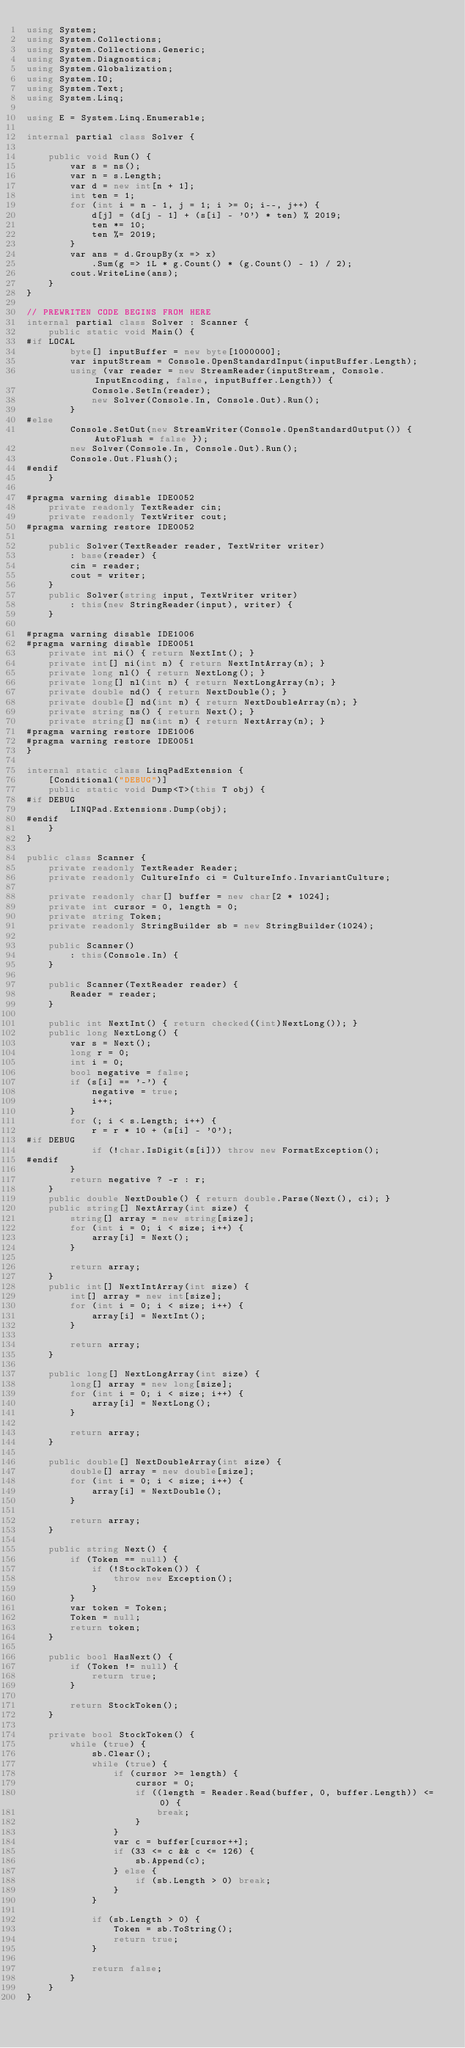<code> <loc_0><loc_0><loc_500><loc_500><_C#_>using System;
using System.Collections;
using System.Collections.Generic;
using System.Diagnostics;
using System.Globalization;
using System.IO;
using System.Text;
using System.Linq;

using E = System.Linq.Enumerable;

internal partial class Solver {

    public void Run() {
        var s = ns();
        var n = s.Length;
        var d = new int[n + 1];
        int ten = 1;
        for (int i = n - 1, j = 1; i >= 0; i--, j++) {
            d[j] = (d[j - 1] + (s[i] - '0') * ten) % 2019;
            ten *= 10;
            ten %= 2019;
        }
        var ans = d.GroupBy(x => x)
            .Sum(g => 1L * g.Count() * (g.Count() - 1) / 2);
        cout.WriteLine(ans);
    }
}

// PREWRITEN CODE BEGINS FROM HERE
internal partial class Solver : Scanner {
    public static void Main() {
#if LOCAL
        byte[] inputBuffer = new byte[1000000];
        var inputStream = Console.OpenStandardInput(inputBuffer.Length);
        using (var reader = new StreamReader(inputStream, Console.InputEncoding, false, inputBuffer.Length)) {
            Console.SetIn(reader);
            new Solver(Console.In, Console.Out).Run();
        }
#else
        Console.SetOut(new StreamWriter(Console.OpenStandardOutput()) { AutoFlush = false });
        new Solver(Console.In, Console.Out).Run();
        Console.Out.Flush();
#endif
    }

#pragma warning disable IDE0052
    private readonly TextReader cin;
    private readonly TextWriter cout;
#pragma warning restore IDE0052

    public Solver(TextReader reader, TextWriter writer)
        : base(reader) {
        cin = reader;
        cout = writer;
    }
    public Solver(string input, TextWriter writer)
        : this(new StringReader(input), writer) {
    }

#pragma warning disable IDE1006
#pragma warning disable IDE0051
    private int ni() { return NextInt(); }
    private int[] ni(int n) { return NextIntArray(n); }
    private long nl() { return NextLong(); }
    private long[] nl(int n) { return NextLongArray(n); }
    private double nd() { return NextDouble(); }
    private double[] nd(int n) { return NextDoubleArray(n); }
    private string ns() { return Next(); }
    private string[] ns(int n) { return NextArray(n); }
#pragma warning restore IDE1006
#pragma warning restore IDE0051
}

internal static class LinqPadExtension {
    [Conditional("DEBUG")]
    public static void Dump<T>(this T obj) {
#if DEBUG
        LINQPad.Extensions.Dump(obj);
#endif
    }
}

public class Scanner {
    private readonly TextReader Reader;
    private readonly CultureInfo ci = CultureInfo.InvariantCulture;

    private readonly char[] buffer = new char[2 * 1024];
    private int cursor = 0, length = 0;
    private string Token;
    private readonly StringBuilder sb = new StringBuilder(1024);

    public Scanner()
        : this(Console.In) {
    }

    public Scanner(TextReader reader) {
        Reader = reader;
    }

    public int NextInt() { return checked((int)NextLong()); }
    public long NextLong() {
        var s = Next();
        long r = 0;
        int i = 0;
        bool negative = false;
        if (s[i] == '-') {
            negative = true;
            i++;
        }
        for (; i < s.Length; i++) {
            r = r * 10 + (s[i] - '0');
#if DEBUG
            if (!char.IsDigit(s[i])) throw new FormatException();
#endif
        }
        return negative ? -r : r;
    }
    public double NextDouble() { return double.Parse(Next(), ci); }
    public string[] NextArray(int size) {
        string[] array = new string[size];
        for (int i = 0; i < size; i++) {
            array[i] = Next();
        }

        return array;
    }
    public int[] NextIntArray(int size) {
        int[] array = new int[size];
        for (int i = 0; i < size; i++) {
            array[i] = NextInt();
        }

        return array;
    }

    public long[] NextLongArray(int size) {
        long[] array = new long[size];
        for (int i = 0; i < size; i++) {
            array[i] = NextLong();
        }

        return array;
    }

    public double[] NextDoubleArray(int size) {
        double[] array = new double[size];
        for (int i = 0; i < size; i++) {
            array[i] = NextDouble();
        }

        return array;
    }

    public string Next() {
        if (Token == null) {
            if (!StockToken()) {
                throw new Exception();
            }
        }
        var token = Token;
        Token = null;
        return token;
    }

    public bool HasNext() {
        if (Token != null) {
            return true;
        }

        return StockToken();
    }

    private bool StockToken() {
        while (true) {
            sb.Clear();
            while (true) {
                if (cursor >= length) {
                    cursor = 0;
                    if ((length = Reader.Read(buffer, 0, buffer.Length)) <= 0) {
                        break;
                    }
                }
                var c = buffer[cursor++];
                if (33 <= c && c <= 126) {
                    sb.Append(c);
                } else {
                    if (sb.Length > 0) break;
                }
            }

            if (sb.Length > 0) {
                Token = sb.ToString();
                return true;
            }

            return false;
        }
    }
}</code> 